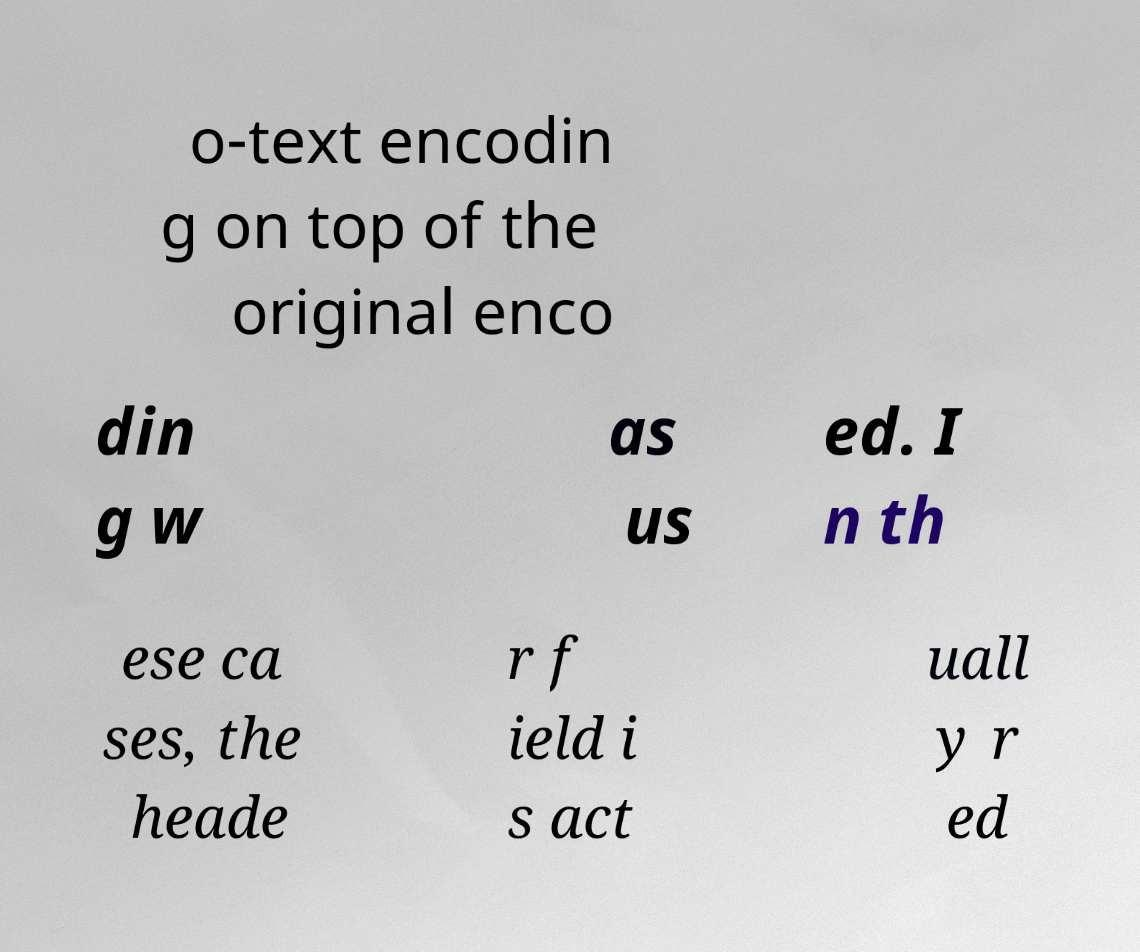Can you read and provide the text displayed in the image?This photo seems to have some interesting text. Can you extract and type it out for me? o-text encodin g on top of the original enco din g w as us ed. I n th ese ca ses, the heade r f ield i s act uall y r ed 